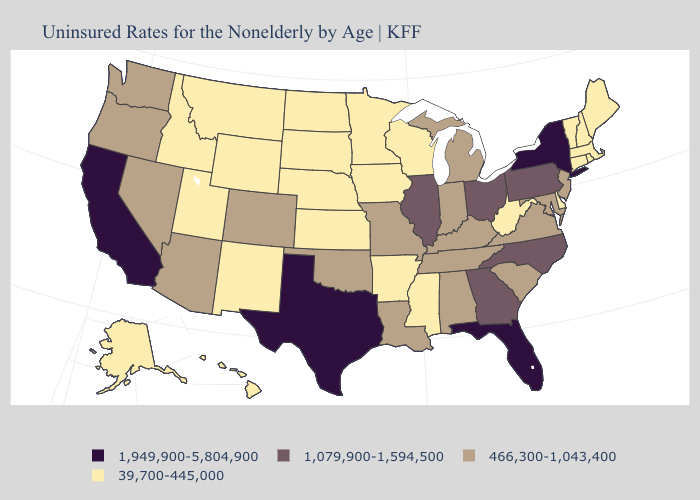Which states have the lowest value in the West?
Concise answer only. Alaska, Hawaii, Idaho, Montana, New Mexico, Utah, Wyoming. Name the states that have a value in the range 1,949,900-5,804,900?
Quick response, please. California, Florida, New York, Texas. What is the value of Iowa?
Be succinct. 39,700-445,000. Which states have the highest value in the USA?
Be succinct. California, Florida, New York, Texas. How many symbols are there in the legend?
Write a very short answer. 4. Which states have the lowest value in the Northeast?
Short answer required. Connecticut, Maine, Massachusetts, New Hampshire, Rhode Island, Vermont. Name the states that have a value in the range 466,300-1,043,400?
Be succinct. Alabama, Arizona, Colorado, Indiana, Kentucky, Louisiana, Maryland, Michigan, Missouri, Nevada, New Jersey, Oklahoma, Oregon, South Carolina, Tennessee, Virginia, Washington. Which states hav the highest value in the MidWest?
Be succinct. Illinois, Ohio. What is the value of Rhode Island?
Quick response, please. 39,700-445,000. What is the highest value in the Northeast ?
Short answer required. 1,949,900-5,804,900. What is the value of California?
Write a very short answer. 1,949,900-5,804,900. Name the states that have a value in the range 466,300-1,043,400?
Keep it brief. Alabama, Arizona, Colorado, Indiana, Kentucky, Louisiana, Maryland, Michigan, Missouri, Nevada, New Jersey, Oklahoma, Oregon, South Carolina, Tennessee, Virginia, Washington. What is the highest value in states that border South Dakota?
Keep it brief. 39,700-445,000. Name the states that have a value in the range 39,700-445,000?
Write a very short answer. Alaska, Arkansas, Connecticut, Delaware, Hawaii, Idaho, Iowa, Kansas, Maine, Massachusetts, Minnesota, Mississippi, Montana, Nebraska, New Hampshire, New Mexico, North Dakota, Rhode Island, South Dakota, Utah, Vermont, West Virginia, Wisconsin, Wyoming. Does the first symbol in the legend represent the smallest category?
Keep it brief. No. 